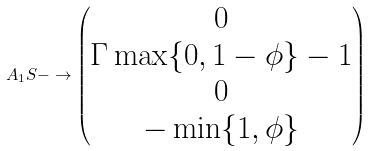Convert formula to latex. <formula><loc_0><loc_0><loc_500><loc_500>A _ { 1 } S - \to \begin{pmatrix} 0 \\ \Gamma \max \{ 0 , 1 - \phi \} - 1 \\ 0 \\ - \min \{ 1 , \phi \} \\ \end{pmatrix}</formula> 